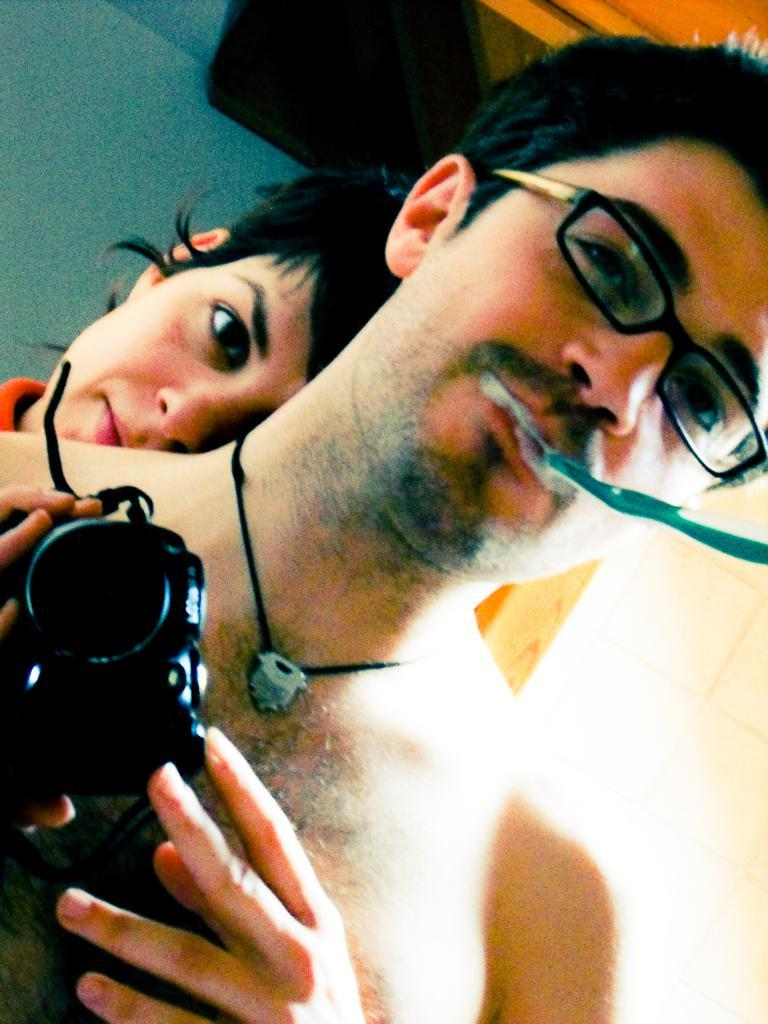What is the man in the image doing? The man is standing and holding a camera in his hands. What is the man holding in his mouth? The man has a toothbrush in his mouth. What accessory is the man wearing? The man is wearing spectacles. Who else is present in the image? There is a woman in the image. What is the woman doing in the image? The woman is standing on the back of the man. What type of animal can be seen in the image? There are no animals present in the image. What kind of flag is visible in the image? There is no flag present in the image. 